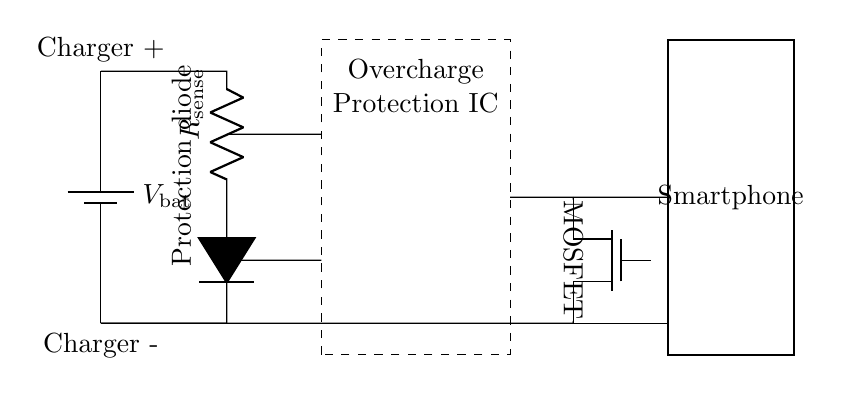What is the type of protection component shown? The diagram includes a full diode labeled "Protection diode," which is used to prevent reverse current flow and protect the circuit.
Answer: Protection diode How many main components are visible in the circuit? The circuit diagram clearly shows five main components: a battery, a resistor, a diode, a MOSFET, and the Overcharge Protection IC.
Answer: Five What does R_sense monitor in this circuit? The resistor labeled R_sense is used to monitor the current flowing into the smartphone battery, helping detect overcharging conditions.
Answer: Current What is the role of the MOSFET in this circuit? The MOSFET acts as a switching component that opens or closes the path to the battery, thus controlling the charging process based on signals from the Overcharge Protection IC.
Answer: Switching Which component is responsible for overcharge protection? The Overcharge Protection IC is designated to regulate charging and prevent battery overcharging by managing the MOSFET operation.
Answer: Overcharge Protection IC What is the connection type between the battery and the charging circuit? The connection between the battery and the charging circuit is made through short connections, indicating a direct line with minimal resistance for efficient battery charging.
Answer: Short What is the expected outcome if the R_sense reading is too high? A high reading on the R_sense means that the current is exceeding safe limits, triggering the Overcharge Protection IC to stop the charging process and protect the smartphone battery.
Answer: Stop charging 